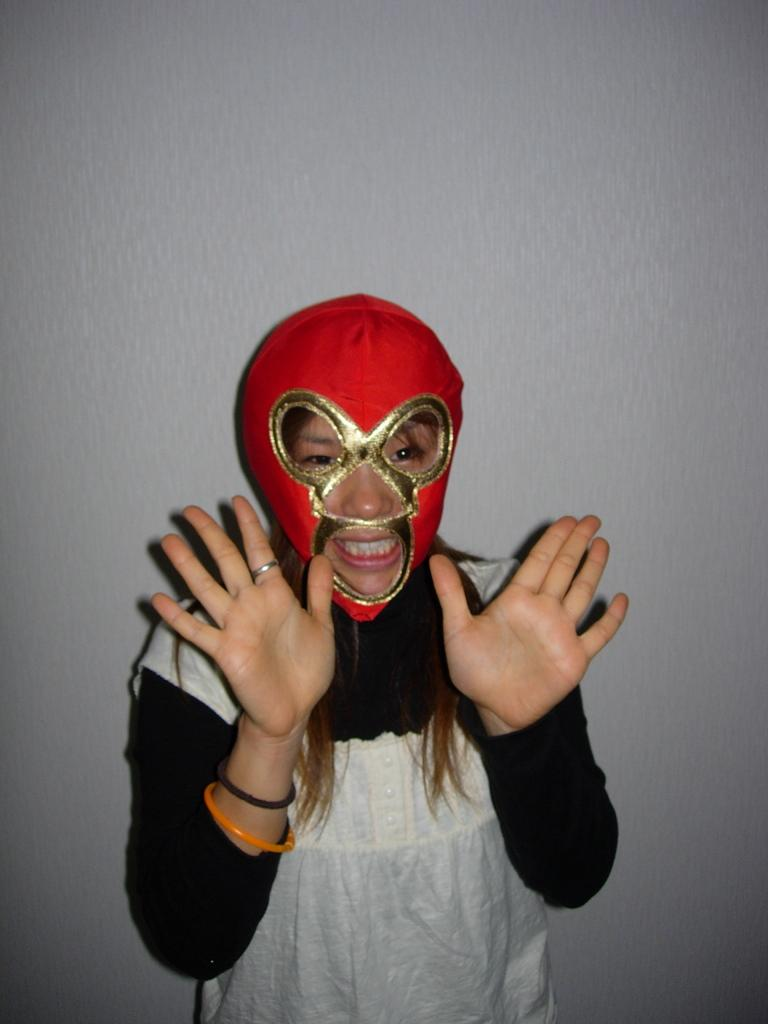Who is present in the image? There is a woman in the image. What is the woman doing in the image? The woman is standing in the image. What is the woman wearing on her head? The woman is wearing a mask on her head. What can be seen in the background of the image? There is a wall in the background of the image. What type of jelly can be seen in the image? There is no jelly present in the image. What kind of music is playing in the background of the image? There is no music playing in the image; it is a still image. 